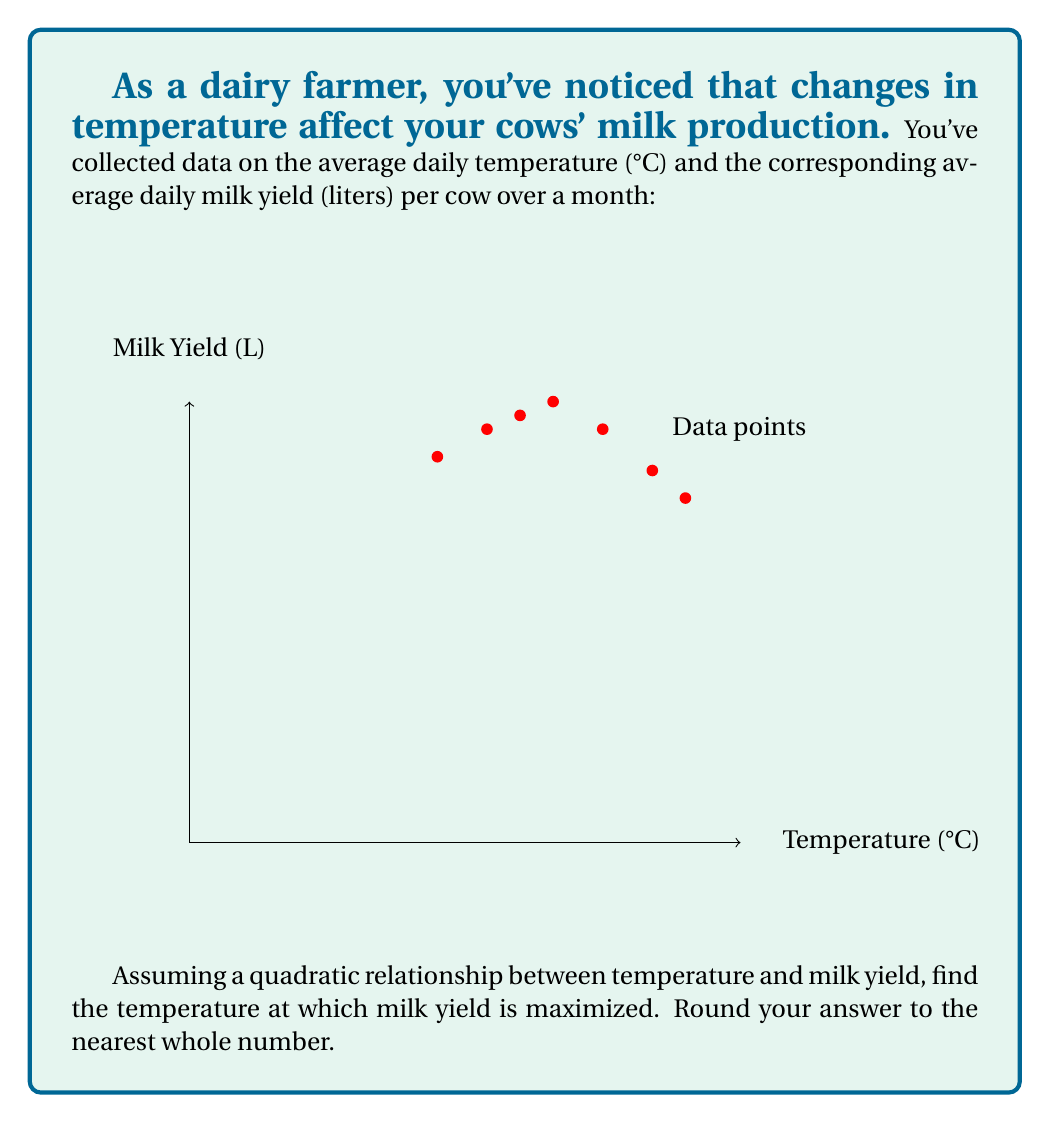Can you solve this math problem? Let's approach this step-by-step:

1) We assume a quadratic relationship of the form:
   $$ y = ax^2 + bx + c $$
   where $y$ is milk yield and $x$ is temperature.

2) To find the coefficients $a$, $b$, and $c$, we can use the least squares method. However, for simplicity, let's use the vertex form of a parabola:
   $$ y = a(x-h)^2 + k $$
   where $(h,k)$ is the vertex of the parabola.

3) From the graph, we can estimate that the vertex is around (22, 32).

4) We can use two other points to determine $a$. Let's use (15, 28) and (30, 25):

   $28 = a(15-22)^2 + 32$
   $25 = a(30-22)^2 + 32$

5) Solving these:
   $28 - 32 = a(-7)^2$
   $25 - 32 = a(8)^2$

   $-4 = 49a$
   $-7 = 64a$

6) Taking the average of these two estimates:
   $a \approx -0.0816 + -0.1094 = -0.0955$

7) Therefore, our model is approximately:
   $$ y = -0.0955(x-22)^2 + 32 $$

8) The vertex of this parabola represents the maximum milk yield, which occurs at $x = 22°C$.
Answer: 22°C 